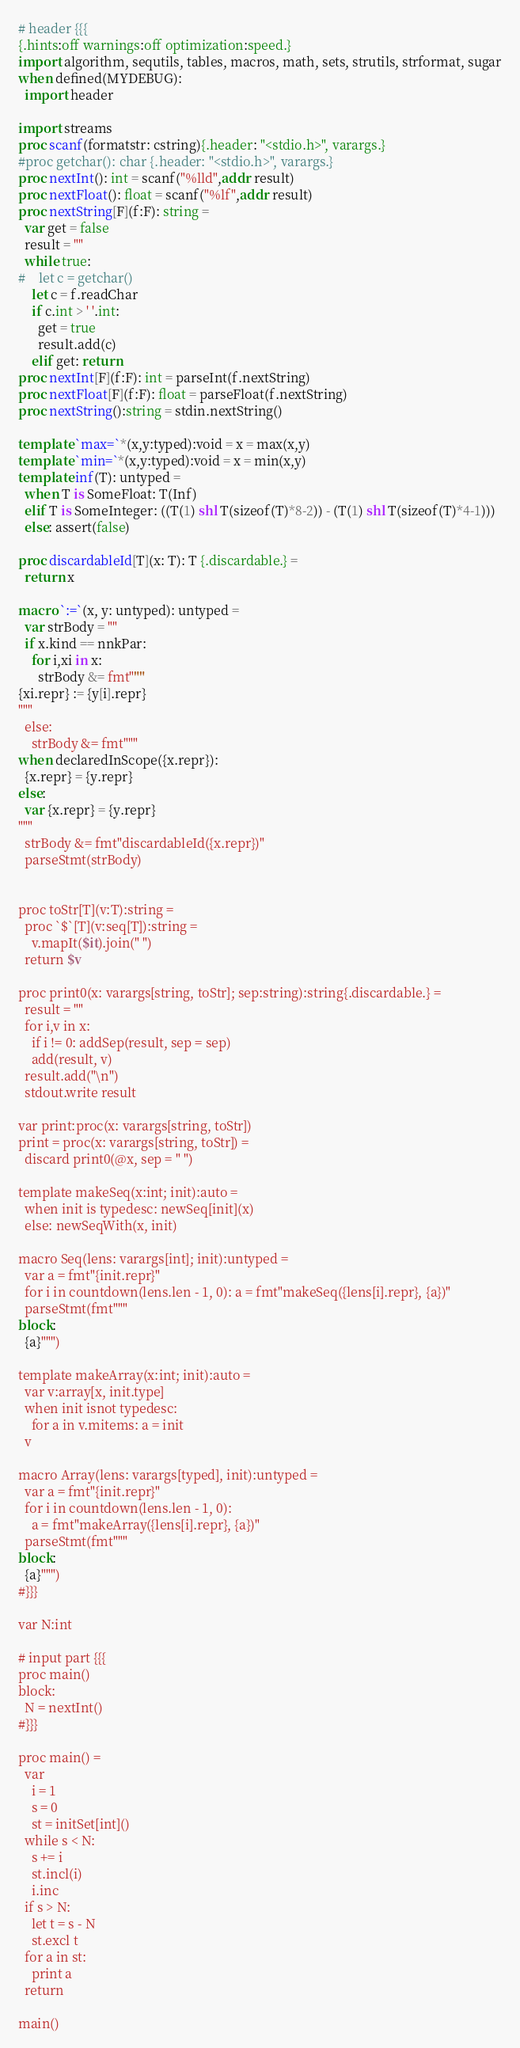Convert code to text. <code><loc_0><loc_0><loc_500><loc_500><_Nim_># header {{{
{.hints:off warnings:off optimization:speed.}
import algorithm, sequtils, tables, macros, math, sets, strutils, strformat, sugar
when defined(MYDEBUG):
  import header

import streams
proc scanf(formatstr: cstring){.header: "<stdio.h>", varargs.}
#proc getchar(): char {.header: "<stdio.h>", varargs.}
proc nextInt(): int = scanf("%lld",addr result)
proc nextFloat(): float = scanf("%lf",addr result)
proc nextString[F](f:F): string =
  var get = false
  result = ""
  while true:
#    let c = getchar()
    let c = f.readChar
    if c.int > ' '.int:
      get = true
      result.add(c)
    elif get: return
proc nextInt[F](f:F): int = parseInt(f.nextString)
proc nextFloat[F](f:F): float = parseFloat(f.nextString)
proc nextString():string = stdin.nextString()

template `max=`*(x,y:typed):void = x = max(x,y)
template `min=`*(x,y:typed):void = x = min(x,y)
template inf(T): untyped = 
  when T is SomeFloat: T(Inf)
  elif T is SomeInteger: ((T(1) shl T(sizeof(T)*8-2)) - (T(1) shl T(sizeof(T)*4-1)))
  else: assert(false)

proc discardableId[T](x: T): T {.discardable.} =
  return x

macro `:=`(x, y: untyped): untyped =
  var strBody = ""
  if x.kind == nnkPar:
    for i,xi in x:
      strBody &= fmt"""
{xi.repr} := {y[i].repr}
"""
  else:
    strBody &= fmt"""
when declaredInScope({x.repr}):
  {x.repr} = {y.repr}
else:
  var {x.repr} = {y.repr}
"""
  strBody &= fmt"discardableId({x.repr})"
  parseStmt(strBody)


proc toStr[T](v:T):string =
  proc `$`[T](v:seq[T]):string =
    v.mapIt($it).join(" ")
  return $v

proc print0(x: varargs[string, toStr]; sep:string):string{.discardable.} =
  result = ""
  for i,v in x:
    if i != 0: addSep(result, sep = sep)
    add(result, v)
  result.add("\n")
  stdout.write result

var print:proc(x: varargs[string, toStr])
print = proc(x: varargs[string, toStr]) =
  discard print0(@x, sep = " ")

template makeSeq(x:int; init):auto =
  when init is typedesc: newSeq[init](x)
  else: newSeqWith(x, init)

macro Seq(lens: varargs[int]; init):untyped =
  var a = fmt"{init.repr}"
  for i in countdown(lens.len - 1, 0): a = fmt"makeSeq({lens[i].repr}, {a})"
  parseStmt(fmt"""
block:
  {a}""")

template makeArray(x:int; init):auto =
  var v:array[x, init.type]
  when init isnot typedesc:
    for a in v.mitems: a = init
  v

macro Array(lens: varargs[typed], init):untyped =
  var a = fmt"{init.repr}"
  for i in countdown(lens.len - 1, 0):
    a = fmt"makeArray({lens[i].repr}, {a})"
  parseStmt(fmt"""
block:
  {a}""")
#}}}

var N:int

# input part {{{
proc main()
block:
  N = nextInt()
#}}}

proc main() =
  var
    i = 1
    s = 0
    st = initSet[int]()
  while s < N:
    s += i
    st.incl(i)
    i.inc
  if s > N:
    let t = s - N
    st.excl t
  for a in st:
    print a
  return

main()

</code> 